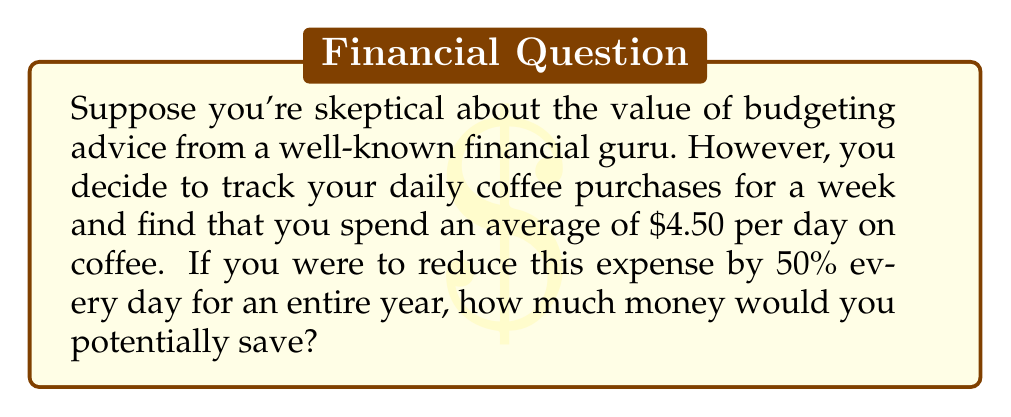Can you answer this question? Let's break this down step-by-step:

1. Calculate the current daily expense:
   $\text{Current daily expense} = $4.50$

2. Calculate the reduced daily expense:
   $\text{Reduced daily expense} = $4.50 \times 0.50 = $2.25$

3. Calculate the daily savings:
   $\text{Daily savings} = \text{Current daily expense} - \text{Reduced daily expense}$
   $\text{Daily savings} = $4.50 - $2.25 = $2.25$

4. Calculate the yearly savings:
   $\text{Yearly savings} = \text{Daily savings} \times \text{Number of days in a year}$
   $\text{Yearly savings} = $2.25 \times 365 = $821.25$

Therefore, by reducing your daily coffee expense by 50% for an entire year, you would potentially save $821.25.
Answer: $821.25 